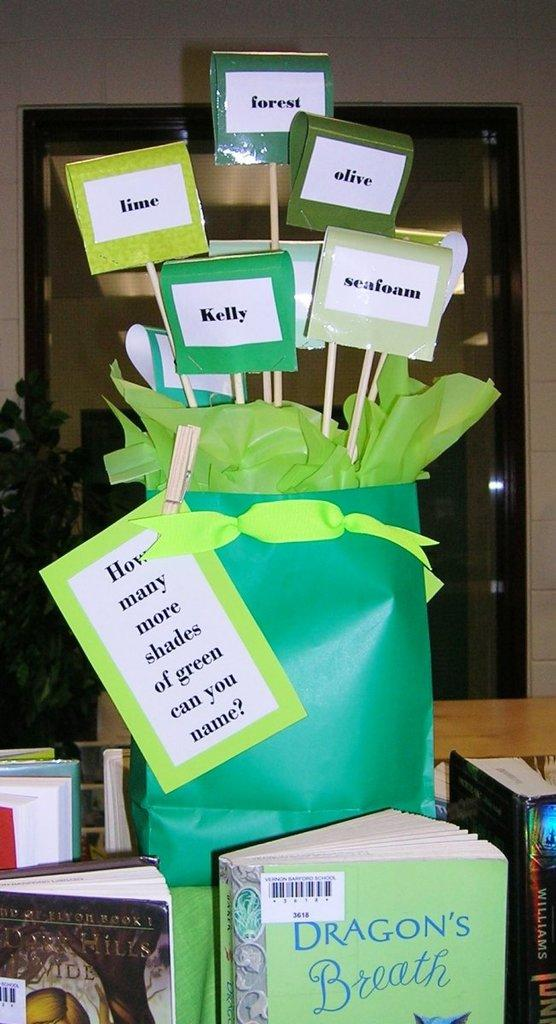<image>
Provide a brief description of the given image. The book Dragon's Beath below a craft asking "How many shades of green can you name?" 